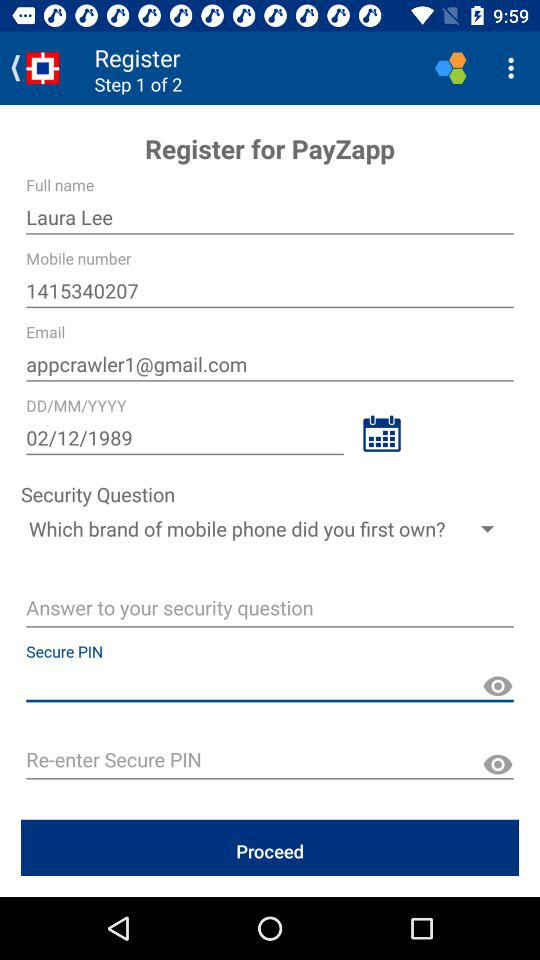What's the birth date? The birth date is February 12, 1989. 